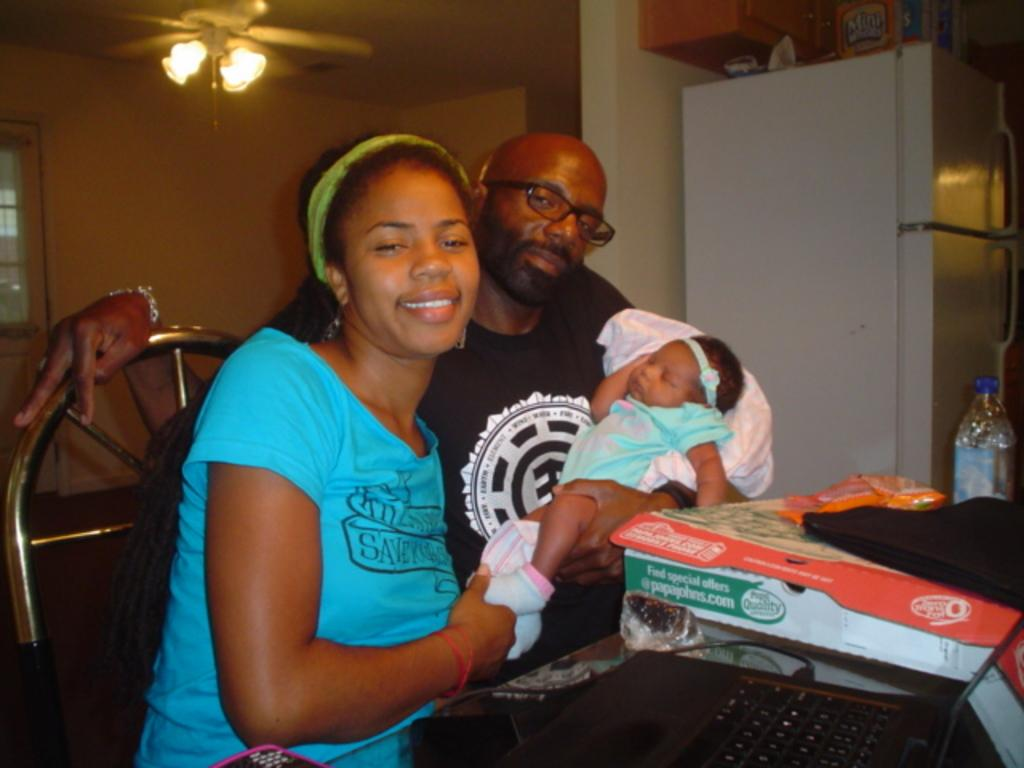How many persons are in the image? There are persons in the image. What electronic device can be seen in the image? There is a laptop in the image. What type of furniture is present in the image? There is a chair in the image. What can be seen in the background of the image? There is a wall, a refrigerator, and a light in the background of the image. Are there any other objects visible in the image? Yes, there are other objects in the image and in the background of the image. How many bottles of wine are visible in the image? There is no wine present in the image. What type of mailbox can be seen in the image? There is no mailbox present in the image. 